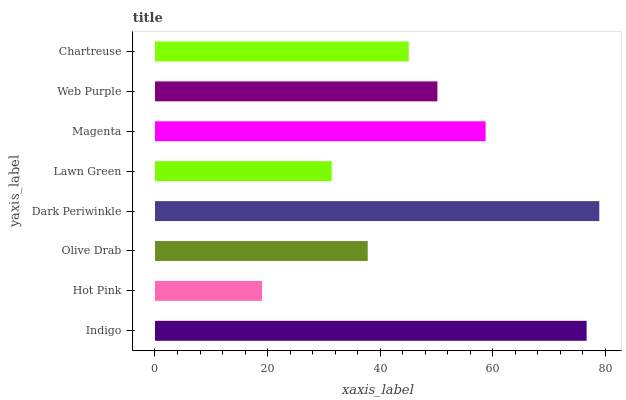Is Hot Pink the minimum?
Answer yes or no. Yes. Is Dark Periwinkle the maximum?
Answer yes or no. Yes. Is Olive Drab the minimum?
Answer yes or no. No. Is Olive Drab the maximum?
Answer yes or no. No. Is Olive Drab greater than Hot Pink?
Answer yes or no. Yes. Is Hot Pink less than Olive Drab?
Answer yes or no. Yes. Is Hot Pink greater than Olive Drab?
Answer yes or no. No. Is Olive Drab less than Hot Pink?
Answer yes or no. No. Is Web Purple the high median?
Answer yes or no. Yes. Is Chartreuse the low median?
Answer yes or no. Yes. Is Indigo the high median?
Answer yes or no. No. Is Dark Periwinkle the low median?
Answer yes or no. No. 